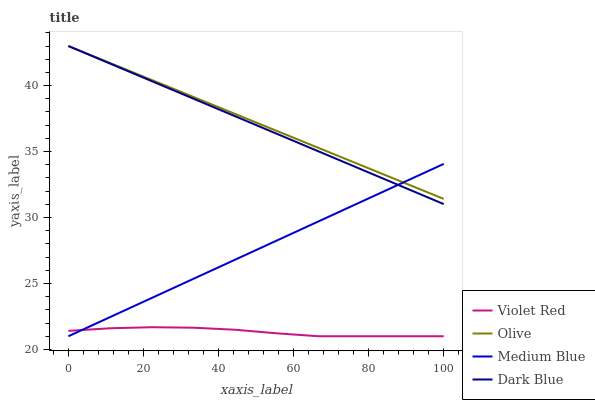Does Violet Red have the minimum area under the curve?
Answer yes or no. Yes. Does Olive have the maximum area under the curve?
Answer yes or no. Yes. Does Dark Blue have the minimum area under the curve?
Answer yes or no. No. Does Dark Blue have the maximum area under the curve?
Answer yes or no. No. Is Medium Blue the smoothest?
Answer yes or no. Yes. Is Violet Red the roughest?
Answer yes or no. Yes. Is Dark Blue the smoothest?
Answer yes or no. No. Is Dark Blue the roughest?
Answer yes or no. No. Does Violet Red have the lowest value?
Answer yes or no. Yes. Does Dark Blue have the lowest value?
Answer yes or no. No. Does Dark Blue have the highest value?
Answer yes or no. Yes. Does Violet Red have the highest value?
Answer yes or no. No. Is Violet Red less than Olive?
Answer yes or no. Yes. Is Dark Blue greater than Violet Red?
Answer yes or no. Yes. Does Medium Blue intersect Dark Blue?
Answer yes or no. Yes. Is Medium Blue less than Dark Blue?
Answer yes or no. No. Is Medium Blue greater than Dark Blue?
Answer yes or no. No. Does Violet Red intersect Olive?
Answer yes or no. No. 